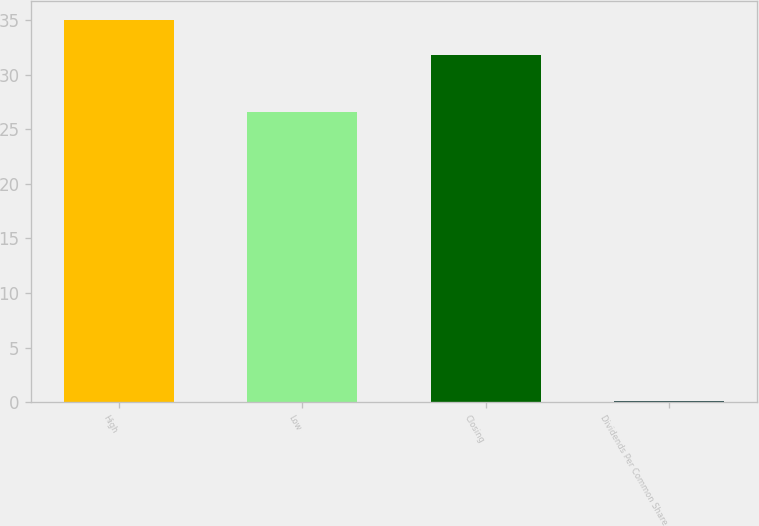Convert chart to OTSL. <chart><loc_0><loc_0><loc_500><loc_500><bar_chart><fcel>High<fcel>Low<fcel>Closing<fcel>Dividends Per Common Share<nl><fcel>34.99<fcel>26.57<fcel>31.8<fcel>0.12<nl></chart> 